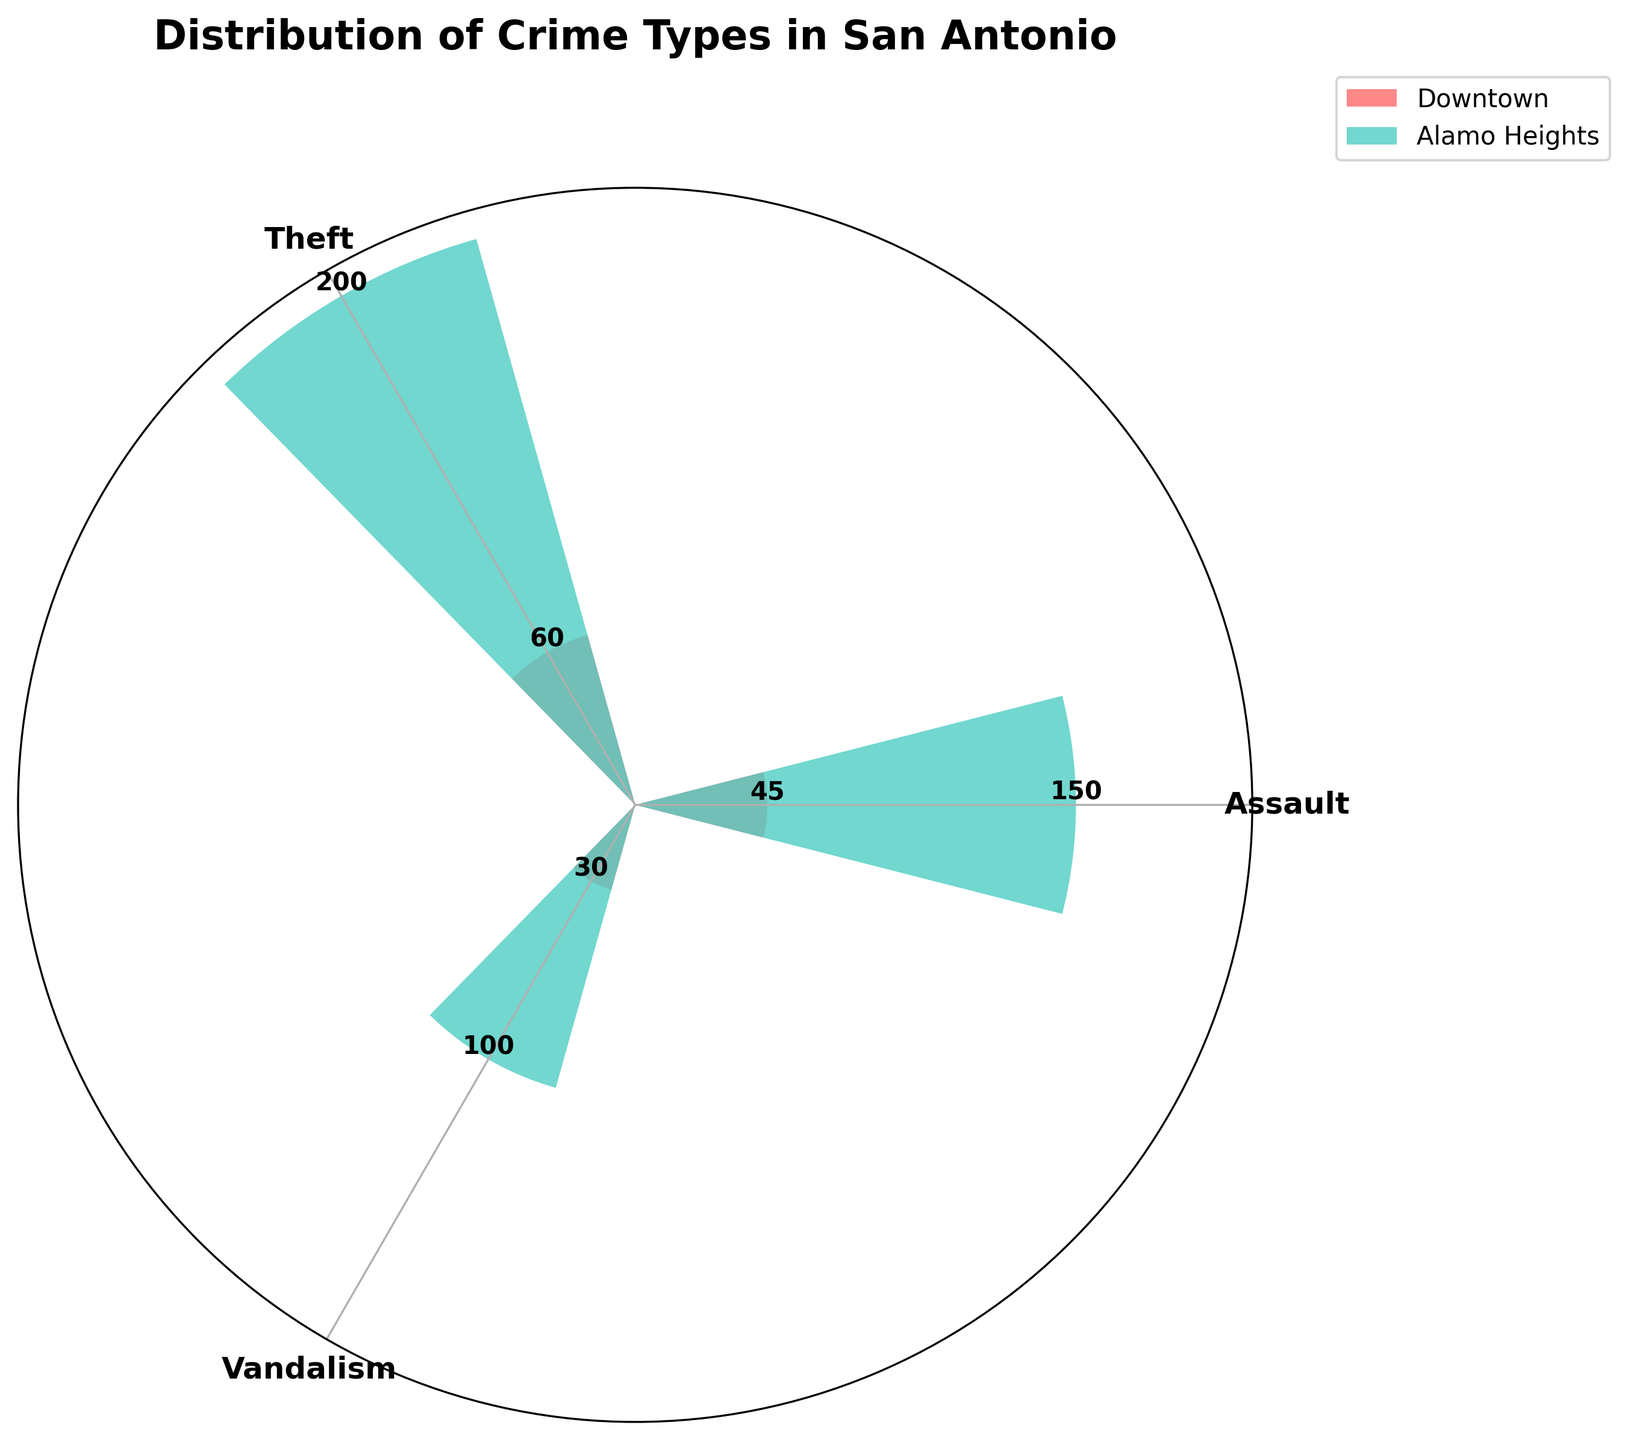What's the title of the figure? The title is usually displayed at the top of the figure. In this case, the title "Distribution of Crime Types in San Antonio" is prominently shown.
Answer: Distribution of Crime Types in San Antonio How many different crime types are displayed in the chart? The chart shows three different segments or areas, each labeled with a specific crime type: Assault, Theft, and Vandalism.
Answer: 3 Which location has the most incidents of theft? By looking at the segments labeled with Theft for both locations, the Downtown section has a larger segment compared to Alamo Heights.
Answer: Downtown What is the total number of incidents displayed in the chart? Add all incidents from the chart: Assault (150 + 45) + Theft (200 + 60) + Vandalism (100 + 30) results in 585.
Answer: 585 Which crime type has the highest number of incidents in Downtown? From the segments labeled Downtown, Theft has the largest, indicating the highest number of incidents with 200.
Answer: Theft What is the difference in the number of assault incidents between Downtown and Alamo Heights? The Downtown segment for Assault shows 150 incidents, and Alamo Heights displays 45. The difference is 150 - 45 = 105 incidents.
Answer: 105 Compare vandalism incidents between the two locations. Which one has fewer and by how much? Downtown has 100 incidents of vandalism, while Alamo Heights has 30. The difference is 100 - 30 = 70.
Answer: Alamo Heights, 70 What is the ratio of theft incidents in Downtown to Alamo Heights? Downtown has 200 incidents of theft, and Alamo Heights has 60. The ratio is 200 to 60, simplified to 10 to 3 or approximately 3.33 to 1.
Answer: 3.33:1 Which crime type has the smallest number of incidents in Alamo Heights? The segments for Alamo Heights show that Vandalism (30) has the smallest segment.
Answer: Vandalism How does the number of assault incidents in Downtown compare to the total number of vandalism incidents across both locations? Assault incidents in Downtown are 150. The total number of vandalism incidents is 100 (Downtown) + 30 (Alamo Heights) = 130. Comparing these, 150 is greater than 130.
Answer: Assault in Downtown > Total Vandalism 